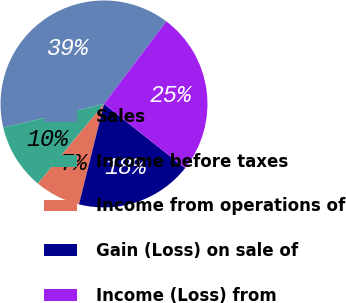Convert chart to OTSL. <chart><loc_0><loc_0><loc_500><loc_500><pie_chart><fcel>Sales<fcel>Income before taxes<fcel>Income from operations of<fcel>Gain (Loss) on sale of<fcel>Income (Loss) from<nl><fcel>38.94%<fcel>10.32%<fcel>7.14%<fcel>18.23%<fcel>25.37%<nl></chart> 